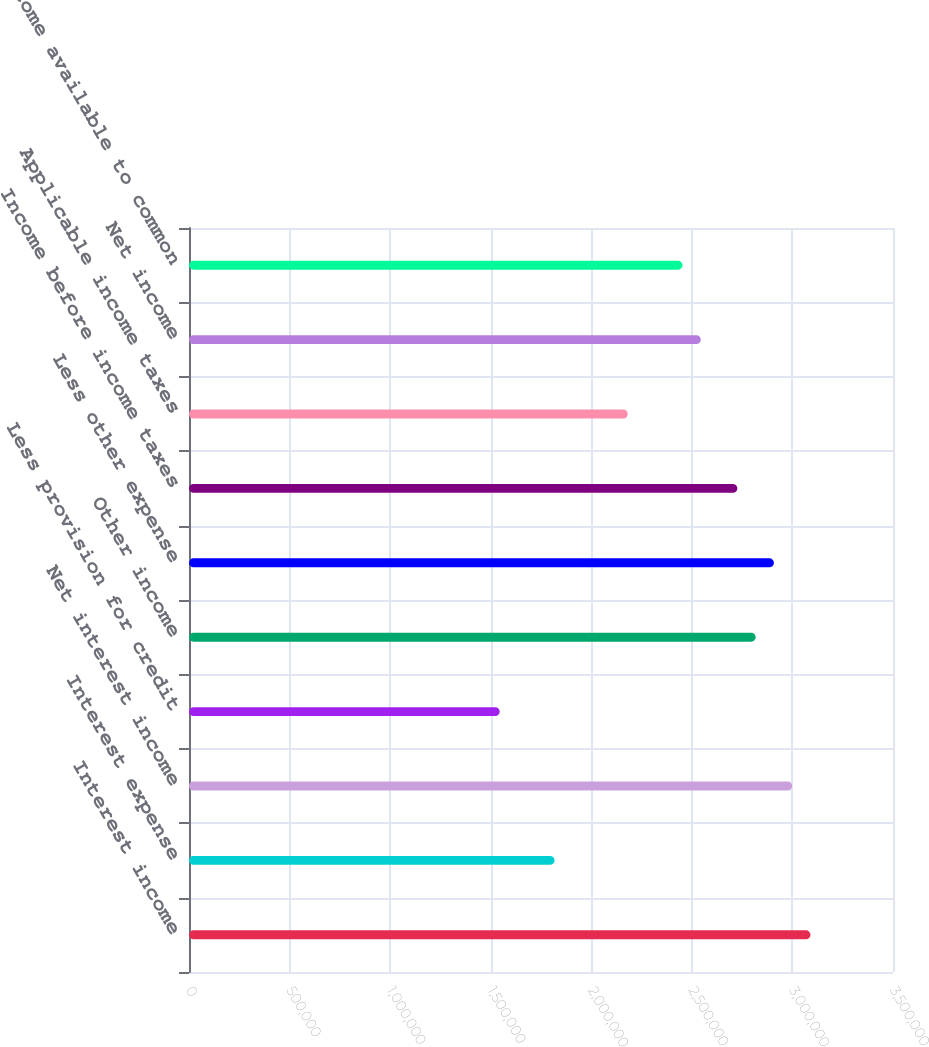Convert chart. <chart><loc_0><loc_0><loc_500><loc_500><bar_chart><fcel>Interest income<fcel>Interest expense<fcel>Net interest income<fcel>Less provision for credit<fcel>Other income<fcel>Less other expense<fcel>Income before income taxes<fcel>Applicable income taxes<fcel>Net income<fcel>Net income available to common<nl><fcel>3.08969e+06<fcel>1.81747e+06<fcel>2.99882e+06<fcel>1.54485e+06<fcel>2.81707e+06<fcel>2.90795e+06<fcel>2.7262e+06<fcel>2.18096e+06<fcel>2.54445e+06<fcel>2.45358e+06<nl></chart> 